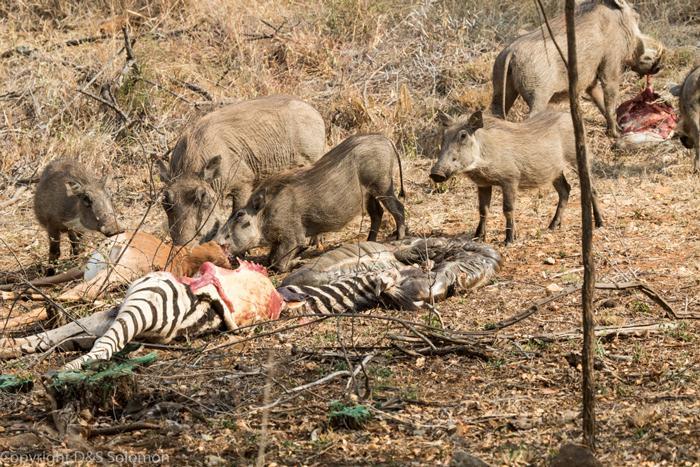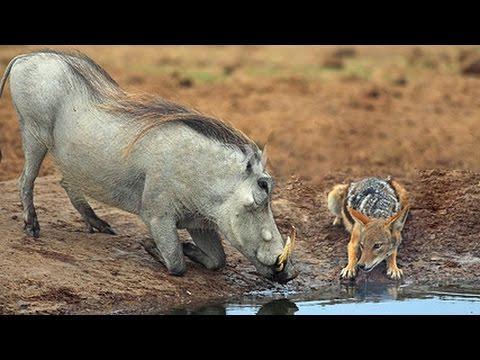The first image is the image on the left, the second image is the image on the right. For the images displayed, is the sentence "There are at least 4 animals." factually correct? Answer yes or no. Yes. The first image is the image on the left, the second image is the image on the right. Given the left and right images, does the statement "All of the wild boars are alive and at least one other type of animal is also alive." hold true? Answer yes or no. Yes. 